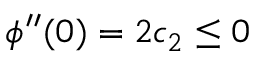<formula> <loc_0><loc_0><loc_500><loc_500>\phi ^ { \prime \prime } ( 0 ) = 2 c _ { 2 } \leq 0</formula> 